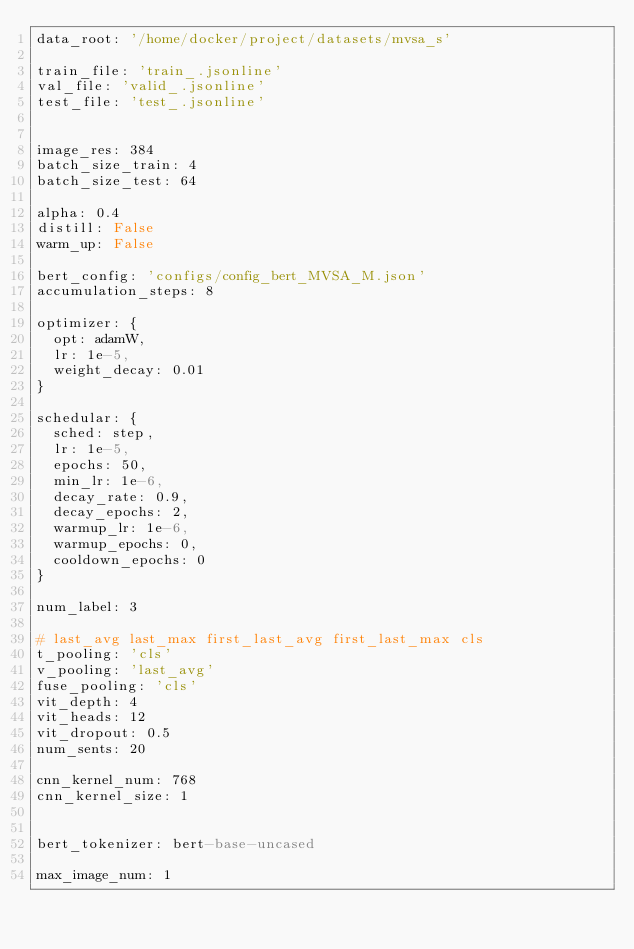Convert code to text. <code><loc_0><loc_0><loc_500><loc_500><_YAML_>data_root: '/home/docker/project/datasets/mvsa_s'

train_file: 'train_.jsonline'
val_file: 'valid_.jsonline'
test_file: 'test_.jsonline'


image_res: 384
batch_size_train: 4
batch_size_test: 64 

alpha: 0.4
distill: False
warm_up: False

bert_config: 'configs/config_bert_MVSA_M.json'
accumulation_steps: 8

optimizer: {
  opt: adamW, 
  lr: 1e-5, 
  weight_decay: 0.01
}

schedular: {
  sched: step, 
  lr: 1e-5, 
  epochs: 50,
  min_lr: 1e-6, 
  decay_rate: 0.9, 
  decay_epochs: 2,
  warmup_lr: 1e-6, 
  warmup_epochs: 0, 
  cooldown_epochs: 0
}

num_label: 3

# last_avg last_max first_last_avg first_last_max cls
t_pooling: 'cls'
v_pooling: 'last_avg'
fuse_pooling: 'cls'
vit_depth: 4
vit_heads: 12
vit_dropout: 0.5
num_sents: 20

cnn_kernel_num: 768
cnn_kernel_size: 1


bert_tokenizer: bert-base-uncased

max_image_num: 1</code> 